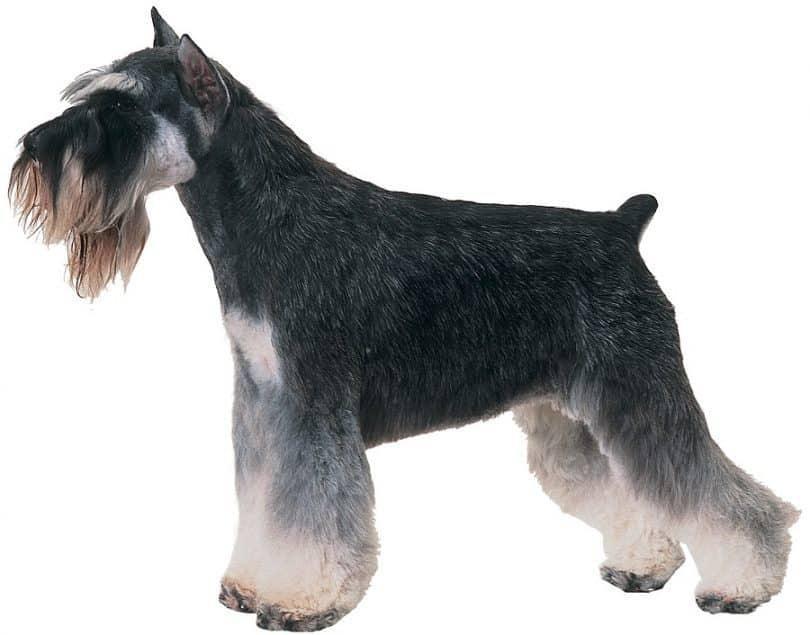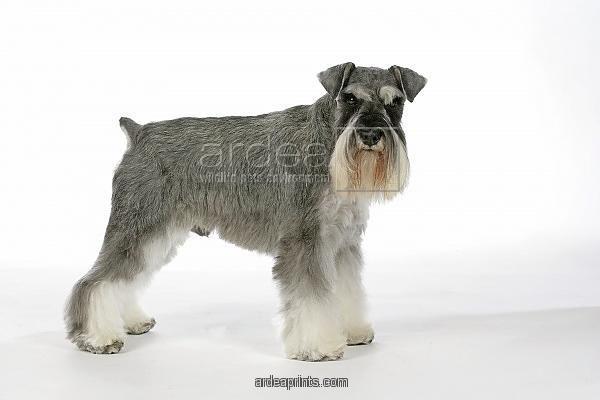The first image is the image on the left, the second image is the image on the right. For the images shown, is this caption "All dogs are facing to the left." true? Answer yes or no. No. 